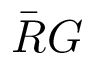Convert formula to latex. <formula><loc_0><loc_0><loc_500><loc_500>\bar { R } G</formula> 